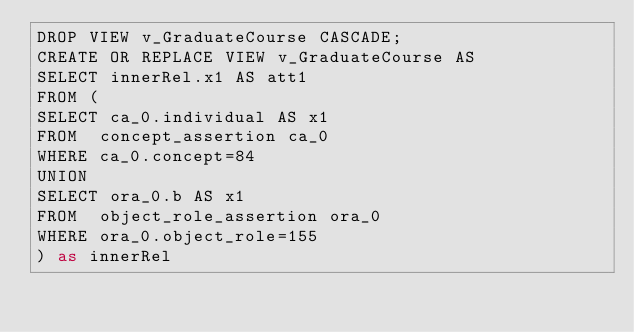<code> <loc_0><loc_0><loc_500><loc_500><_SQL_>DROP VIEW v_GraduateCourse CASCADE;
CREATE OR REPLACE VIEW v_GraduateCourse AS 
SELECT innerRel.x1 AS att1
FROM (
SELECT ca_0.individual AS x1
FROM  concept_assertion ca_0
WHERE ca_0.concept=84
UNION 
SELECT ora_0.b AS x1
FROM  object_role_assertion ora_0
WHERE ora_0.object_role=155
) as innerRel
</code> 